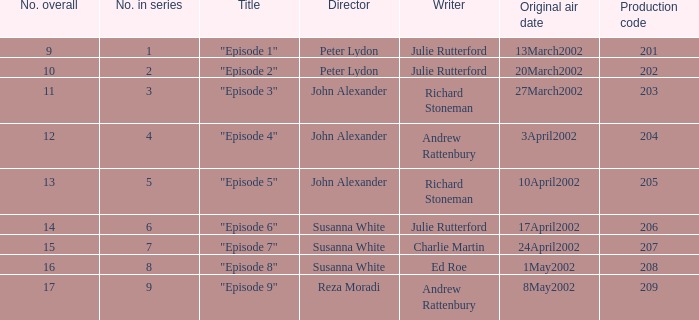When 15 is the number overall what is the original air date? 24April2002. 